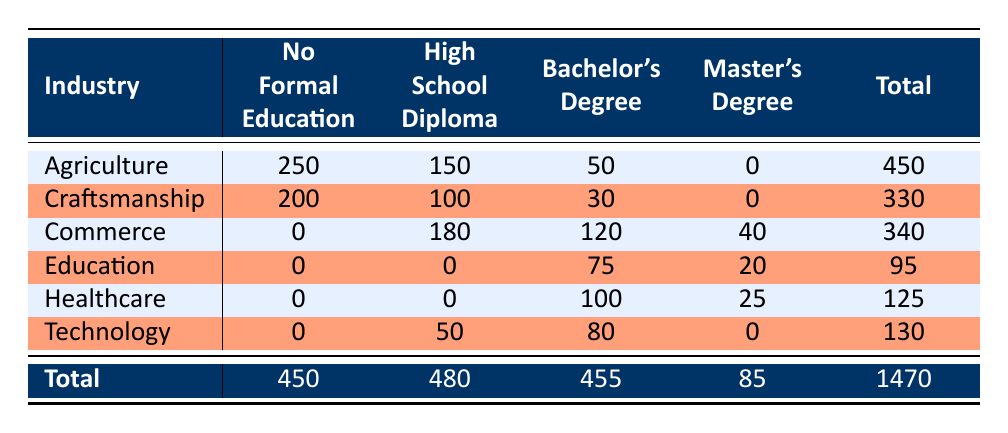What is the total number of employed Elbegli tribe members in the Agriculture industry? From the table, the Employment Count for Agriculture is 250 (No Formal Education) + 150 (High School Diploma) + 50 (Bachelor's Degree) = 450.
Answer: 450 Which industry has the highest number of employees with a High School Diploma? The total Employment Count for High School Diploma in various industries is as follows: Agriculture 150, Craftsmanship 100, Commerce 180, Education 0, Healthcare 0, and Technology 50. The highest is in the Commerce industry with 180 employees.
Answer: Commerce Is there anyone in the Elbegli tribe employed in Education with No Formal Education? According to the table, the Employment Count for Education with No Formal Education is 0.
Answer: No What is the average number of employees across all industries for those with a Master's Degree? The Employment Count for Master's Degree is: Commerce 40, Education 20, Healthcare 25, and no other industry has any employees with a Master's degree, totaling 40 + 20 + 25 = 85. There are 3 entries for Master’s Degree (Commerce, Education, Healthcare), so the average is 85/3 = approximately 28.33.
Answer: 28.33 How many more members are employed in Agriculture than in Craftsmanship? The total Employment Count for Agriculture is 450 and for Craftsmanship is 330. To find the difference, we subtract: 450 - 330 = 120.
Answer: 120 What percentage of the total employment does the Technology industry hold? The total Employment Count in Technology is 130. The overall total is 1470. To find the percentage, we use the formula (130/1470) * 100, which gives us approximately 8.84%.
Answer: 8.84% Are there more tribe members employed in Healthcare with a Bachelor's Degree than in the Commerce industry with a Master's Degree? The Employment Count for Healthcare with a Bachelor's Degree is 100, while for Commerce with a Master's Degree, it is 40. Since 100 > 40, this statement is true.
Answer: Yes What is the total employment for members with a Bachelor's Degree? Summing the Employment Counts with a Bachelor's Degree across industries gives us: Agriculture 50 + Craftsmanship 30 + Commerce 120 + Education 75 + Healthcare 100 + Technology 80 = 455.
Answer: 455 